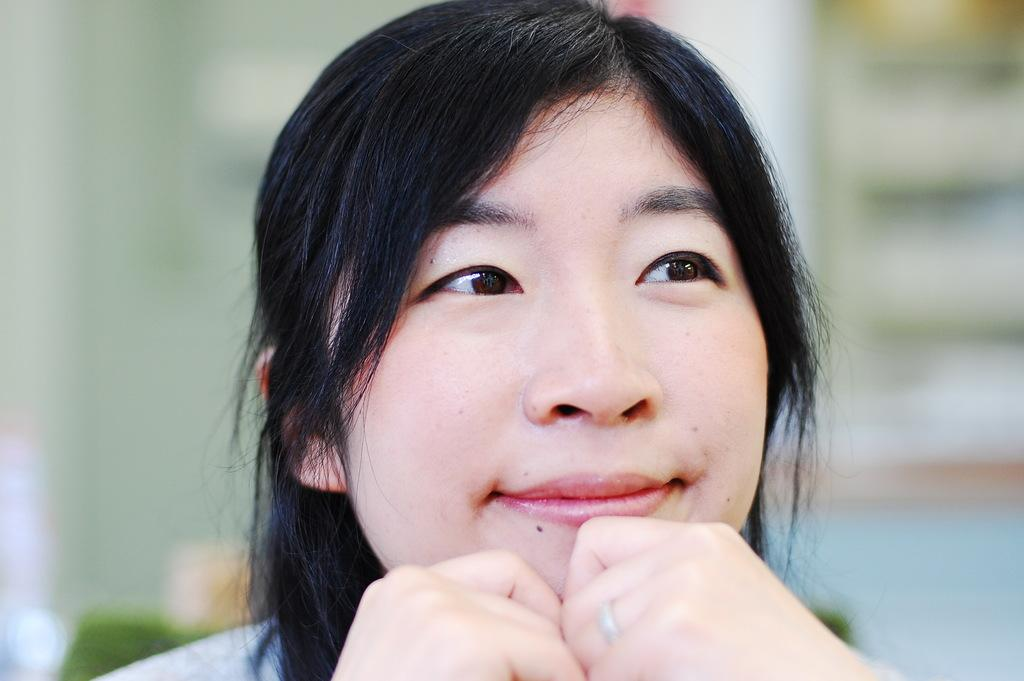Who is the main subject in the image? There is a woman in the image. Can you describe the background of the image? The background of the image is blurry. What type of kite is the woman flying in the image? There is no kite present in the image. How does the acoustics of the woman's voice sound in the image? The image does not provide any information about the acoustics of the woman's voice. 